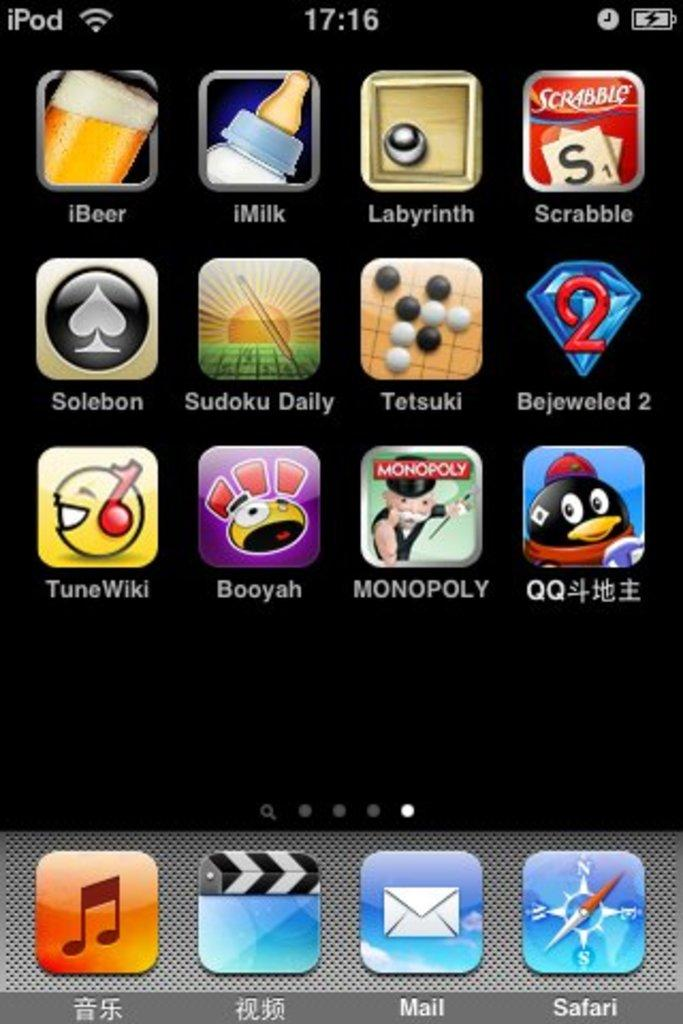<image>
Offer a succinct explanation of the picture presented. Screen shot of different apps like Monopoly and Scrabble on a black background with the battery charging. 